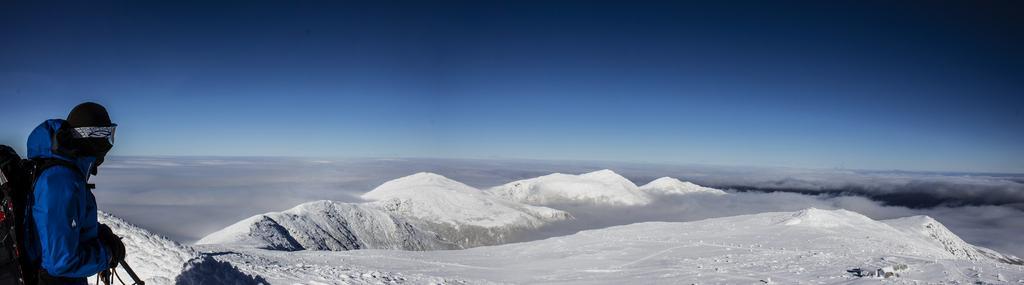In one or two sentences, can you explain what this image depicts? In the background we can see the sky, clouds and hills. On the left side of the picture we can see a person wearing a jacket and backpack.  